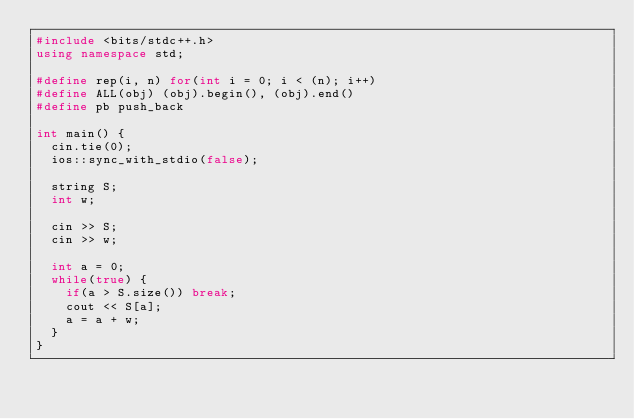Convert code to text. <code><loc_0><loc_0><loc_500><loc_500><_C++_>#include <bits/stdc++.h>
using namespace std;
 
#define rep(i, n) for(int i = 0; i < (n); i++)
#define ALL(obj) (obj).begin(), (obj).end()
#define pb push_back
 
int main() {
  cin.tie(0);
  ios::sync_with_stdio(false);
 
  string S;
  int w;
 
  cin >> S;
  cin >> w;
 
  int a = 0;
  while(true) {
    if(a > S.size()) break;
    cout << S[a];
    a = a + w;
  }
}</code> 